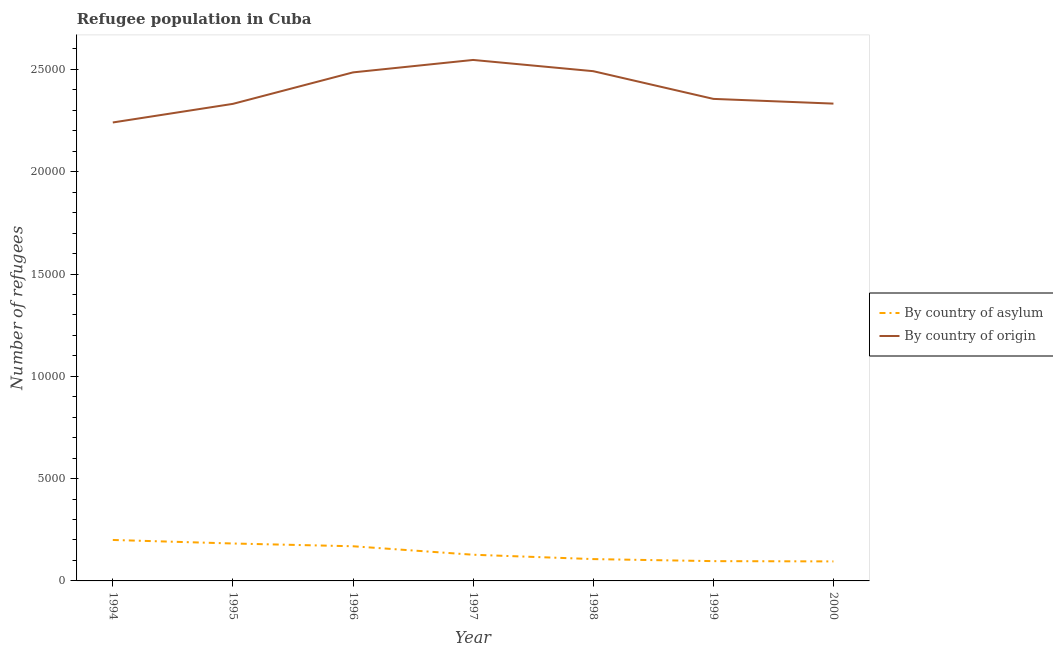Is the number of lines equal to the number of legend labels?
Offer a very short reply. Yes. What is the number of refugees by country of origin in 1999?
Make the answer very short. 2.36e+04. Across all years, what is the maximum number of refugees by country of asylum?
Ensure brevity in your answer.  2002. Across all years, what is the minimum number of refugees by country of origin?
Provide a succinct answer. 2.24e+04. In which year was the number of refugees by country of asylum maximum?
Your answer should be very brief. 1994. What is the total number of refugees by country of origin in the graph?
Offer a terse response. 1.68e+05. What is the difference between the number of refugees by country of asylum in 1998 and that in 2000?
Provide a succinct answer. 113. What is the difference between the number of refugees by country of origin in 1998 and the number of refugees by country of asylum in 2000?
Your answer should be very brief. 2.40e+04. What is the average number of refugees by country of asylum per year?
Provide a short and direct response. 1399. In the year 1997, what is the difference between the number of refugees by country of origin and number of refugees by country of asylum?
Your answer should be compact. 2.42e+04. What is the ratio of the number of refugees by country of asylum in 1996 to that in 1998?
Provide a succinct answer. 1.59. What is the difference between the highest and the second highest number of refugees by country of asylum?
Offer a very short reply. 173. What is the difference between the highest and the lowest number of refugees by country of asylum?
Your response must be concise. 1048. Is the sum of the number of refugees by country of origin in 1998 and 2000 greater than the maximum number of refugees by country of asylum across all years?
Give a very brief answer. Yes. Does the number of refugees by country of origin monotonically increase over the years?
Make the answer very short. No. Is the number of refugees by country of origin strictly greater than the number of refugees by country of asylum over the years?
Give a very brief answer. Yes. Is the number of refugees by country of origin strictly less than the number of refugees by country of asylum over the years?
Provide a succinct answer. No. What is the difference between two consecutive major ticks on the Y-axis?
Keep it short and to the point. 5000. Does the graph contain grids?
Keep it short and to the point. No. How many legend labels are there?
Your answer should be compact. 2. What is the title of the graph?
Provide a short and direct response. Refugee population in Cuba. What is the label or title of the X-axis?
Keep it short and to the point. Year. What is the label or title of the Y-axis?
Ensure brevity in your answer.  Number of refugees. What is the Number of refugees in By country of asylum in 1994?
Your answer should be compact. 2002. What is the Number of refugees of By country of origin in 1994?
Make the answer very short. 2.24e+04. What is the Number of refugees of By country of asylum in 1995?
Offer a very short reply. 1829. What is the Number of refugees of By country of origin in 1995?
Offer a terse response. 2.33e+04. What is the Number of refugees of By country of asylum in 1996?
Provide a short and direct response. 1694. What is the Number of refugees of By country of origin in 1996?
Offer a terse response. 2.49e+04. What is the Number of refugees of By country of asylum in 1997?
Offer a terse response. 1280. What is the Number of refugees of By country of origin in 1997?
Your answer should be compact. 2.55e+04. What is the Number of refugees of By country of asylum in 1998?
Give a very brief answer. 1067. What is the Number of refugees of By country of origin in 1998?
Ensure brevity in your answer.  2.49e+04. What is the Number of refugees in By country of asylum in 1999?
Keep it short and to the point. 967. What is the Number of refugees of By country of origin in 1999?
Provide a succinct answer. 2.36e+04. What is the Number of refugees of By country of asylum in 2000?
Provide a short and direct response. 954. What is the Number of refugees of By country of origin in 2000?
Keep it short and to the point. 2.33e+04. Across all years, what is the maximum Number of refugees in By country of asylum?
Make the answer very short. 2002. Across all years, what is the maximum Number of refugees of By country of origin?
Offer a very short reply. 2.55e+04. Across all years, what is the minimum Number of refugees of By country of asylum?
Offer a very short reply. 954. Across all years, what is the minimum Number of refugees of By country of origin?
Provide a succinct answer. 2.24e+04. What is the total Number of refugees of By country of asylum in the graph?
Offer a terse response. 9793. What is the total Number of refugees in By country of origin in the graph?
Ensure brevity in your answer.  1.68e+05. What is the difference between the Number of refugees in By country of asylum in 1994 and that in 1995?
Your answer should be very brief. 173. What is the difference between the Number of refugees of By country of origin in 1994 and that in 1995?
Your answer should be very brief. -910. What is the difference between the Number of refugees of By country of asylum in 1994 and that in 1996?
Make the answer very short. 308. What is the difference between the Number of refugees of By country of origin in 1994 and that in 1996?
Keep it short and to the point. -2448. What is the difference between the Number of refugees in By country of asylum in 1994 and that in 1997?
Provide a succinct answer. 722. What is the difference between the Number of refugees in By country of origin in 1994 and that in 1997?
Keep it short and to the point. -3056. What is the difference between the Number of refugees in By country of asylum in 1994 and that in 1998?
Offer a very short reply. 935. What is the difference between the Number of refugees of By country of origin in 1994 and that in 1998?
Provide a short and direct response. -2507. What is the difference between the Number of refugees of By country of asylum in 1994 and that in 1999?
Keep it short and to the point. 1035. What is the difference between the Number of refugees in By country of origin in 1994 and that in 1999?
Keep it short and to the point. -1153. What is the difference between the Number of refugees of By country of asylum in 1994 and that in 2000?
Your answer should be compact. 1048. What is the difference between the Number of refugees in By country of origin in 1994 and that in 2000?
Give a very brief answer. -922. What is the difference between the Number of refugees in By country of asylum in 1995 and that in 1996?
Make the answer very short. 135. What is the difference between the Number of refugees of By country of origin in 1995 and that in 1996?
Ensure brevity in your answer.  -1538. What is the difference between the Number of refugees of By country of asylum in 1995 and that in 1997?
Keep it short and to the point. 549. What is the difference between the Number of refugees in By country of origin in 1995 and that in 1997?
Ensure brevity in your answer.  -2146. What is the difference between the Number of refugees in By country of asylum in 1995 and that in 1998?
Your answer should be very brief. 762. What is the difference between the Number of refugees of By country of origin in 1995 and that in 1998?
Your response must be concise. -1597. What is the difference between the Number of refugees of By country of asylum in 1995 and that in 1999?
Your response must be concise. 862. What is the difference between the Number of refugees in By country of origin in 1995 and that in 1999?
Give a very brief answer. -243. What is the difference between the Number of refugees in By country of asylum in 1995 and that in 2000?
Make the answer very short. 875. What is the difference between the Number of refugees of By country of origin in 1995 and that in 2000?
Provide a short and direct response. -12. What is the difference between the Number of refugees in By country of asylum in 1996 and that in 1997?
Provide a succinct answer. 414. What is the difference between the Number of refugees of By country of origin in 1996 and that in 1997?
Offer a terse response. -608. What is the difference between the Number of refugees of By country of asylum in 1996 and that in 1998?
Your answer should be compact. 627. What is the difference between the Number of refugees of By country of origin in 1996 and that in 1998?
Offer a terse response. -59. What is the difference between the Number of refugees in By country of asylum in 1996 and that in 1999?
Offer a very short reply. 727. What is the difference between the Number of refugees of By country of origin in 1996 and that in 1999?
Make the answer very short. 1295. What is the difference between the Number of refugees of By country of asylum in 1996 and that in 2000?
Offer a terse response. 740. What is the difference between the Number of refugees in By country of origin in 1996 and that in 2000?
Provide a succinct answer. 1526. What is the difference between the Number of refugees of By country of asylum in 1997 and that in 1998?
Make the answer very short. 213. What is the difference between the Number of refugees in By country of origin in 1997 and that in 1998?
Offer a terse response. 549. What is the difference between the Number of refugees of By country of asylum in 1997 and that in 1999?
Offer a very short reply. 313. What is the difference between the Number of refugees of By country of origin in 1997 and that in 1999?
Keep it short and to the point. 1903. What is the difference between the Number of refugees in By country of asylum in 1997 and that in 2000?
Your response must be concise. 326. What is the difference between the Number of refugees in By country of origin in 1997 and that in 2000?
Provide a short and direct response. 2134. What is the difference between the Number of refugees in By country of origin in 1998 and that in 1999?
Ensure brevity in your answer.  1354. What is the difference between the Number of refugees of By country of asylum in 1998 and that in 2000?
Provide a succinct answer. 113. What is the difference between the Number of refugees in By country of origin in 1998 and that in 2000?
Your answer should be compact. 1585. What is the difference between the Number of refugees of By country of origin in 1999 and that in 2000?
Provide a short and direct response. 231. What is the difference between the Number of refugees in By country of asylum in 1994 and the Number of refugees in By country of origin in 1995?
Your answer should be compact. -2.13e+04. What is the difference between the Number of refugees in By country of asylum in 1994 and the Number of refugees in By country of origin in 1996?
Provide a succinct answer. -2.29e+04. What is the difference between the Number of refugees in By country of asylum in 1994 and the Number of refugees in By country of origin in 1997?
Your answer should be very brief. -2.35e+04. What is the difference between the Number of refugees in By country of asylum in 1994 and the Number of refugees in By country of origin in 1998?
Your response must be concise. -2.29e+04. What is the difference between the Number of refugees of By country of asylum in 1994 and the Number of refugees of By country of origin in 1999?
Your response must be concise. -2.16e+04. What is the difference between the Number of refugees in By country of asylum in 1994 and the Number of refugees in By country of origin in 2000?
Make the answer very short. -2.13e+04. What is the difference between the Number of refugees in By country of asylum in 1995 and the Number of refugees in By country of origin in 1996?
Offer a very short reply. -2.30e+04. What is the difference between the Number of refugees of By country of asylum in 1995 and the Number of refugees of By country of origin in 1997?
Make the answer very short. -2.36e+04. What is the difference between the Number of refugees of By country of asylum in 1995 and the Number of refugees of By country of origin in 1998?
Offer a terse response. -2.31e+04. What is the difference between the Number of refugees in By country of asylum in 1995 and the Number of refugees in By country of origin in 1999?
Provide a succinct answer. -2.17e+04. What is the difference between the Number of refugees of By country of asylum in 1995 and the Number of refugees of By country of origin in 2000?
Your answer should be compact. -2.15e+04. What is the difference between the Number of refugees in By country of asylum in 1996 and the Number of refugees in By country of origin in 1997?
Make the answer very short. -2.38e+04. What is the difference between the Number of refugees in By country of asylum in 1996 and the Number of refugees in By country of origin in 1998?
Make the answer very short. -2.32e+04. What is the difference between the Number of refugees of By country of asylum in 1996 and the Number of refugees of By country of origin in 1999?
Your response must be concise. -2.19e+04. What is the difference between the Number of refugees in By country of asylum in 1996 and the Number of refugees in By country of origin in 2000?
Keep it short and to the point. -2.16e+04. What is the difference between the Number of refugees of By country of asylum in 1997 and the Number of refugees of By country of origin in 1998?
Give a very brief answer. -2.36e+04. What is the difference between the Number of refugees in By country of asylum in 1997 and the Number of refugees in By country of origin in 1999?
Make the answer very short. -2.23e+04. What is the difference between the Number of refugees in By country of asylum in 1997 and the Number of refugees in By country of origin in 2000?
Your answer should be very brief. -2.20e+04. What is the difference between the Number of refugees in By country of asylum in 1998 and the Number of refugees in By country of origin in 1999?
Provide a succinct answer. -2.25e+04. What is the difference between the Number of refugees in By country of asylum in 1998 and the Number of refugees in By country of origin in 2000?
Offer a very short reply. -2.23e+04. What is the difference between the Number of refugees of By country of asylum in 1999 and the Number of refugees of By country of origin in 2000?
Provide a succinct answer. -2.24e+04. What is the average Number of refugees in By country of asylum per year?
Your response must be concise. 1399. What is the average Number of refugees of By country of origin per year?
Your response must be concise. 2.40e+04. In the year 1994, what is the difference between the Number of refugees in By country of asylum and Number of refugees in By country of origin?
Provide a short and direct response. -2.04e+04. In the year 1995, what is the difference between the Number of refugees of By country of asylum and Number of refugees of By country of origin?
Provide a short and direct response. -2.15e+04. In the year 1996, what is the difference between the Number of refugees in By country of asylum and Number of refugees in By country of origin?
Ensure brevity in your answer.  -2.32e+04. In the year 1997, what is the difference between the Number of refugees in By country of asylum and Number of refugees in By country of origin?
Offer a very short reply. -2.42e+04. In the year 1998, what is the difference between the Number of refugees of By country of asylum and Number of refugees of By country of origin?
Your answer should be compact. -2.38e+04. In the year 1999, what is the difference between the Number of refugees of By country of asylum and Number of refugees of By country of origin?
Keep it short and to the point. -2.26e+04. In the year 2000, what is the difference between the Number of refugees in By country of asylum and Number of refugees in By country of origin?
Make the answer very short. -2.24e+04. What is the ratio of the Number of refugees of By country of asylum in 1994 to that in 1995?
Offer a very short reply. 1.09. What is the ratio of the Number of refugees of By country of origin in 1994 to that in 1995?
Your answer should be compact. 0.96. What is the ratio of the Number of refugees in By country of asylum in 1994 to that in 1996?
Your answer should be compact. 1.18. What is the ratio of the Number of refugees of By country of origin in 1994 to that in 1996?
Your response must be concise. 0.9. What is the ratio of the Number of refugees in By country of asylum in 1994 to that in 1997?
Your response must be concise. 1.56. What is the ratio of the Number of refugees of By country of origin in 1994 to that in 1997?
Provide a short and direct response. 0.88. What is the ratio of the Number of refugees of By country of asylum in 1994 to that in 1998?
Offer a very short reply. 1.88. What is the ratio of the Number of refugees in By country of origin in 1994 to that in 1998?
Provide a short and direct response. 0.9. What is the ratio of the Number of refugees in By country of asylum in 1994 to that in 1999?
Ensure brevity in your answer.  2.07. What is the ratio of the Number of refugees of By country of origin in 1994 to that in 1999?
Make the answer very short. 0.95. What is the ratio of the Number of refugees in By country of asylum in 1994 to that in 2000?
Provide a succinct answer. 2.1. What is the ratio of the Number of refugees in By country of origin in 1994 to that in 2000?
Provide a succinct answer. 0.96. What is the ratio of the Number of refugees in By country of asylum in 1995 to that in 1996?
Offer a very short reply. 1.08. What is the ratio of the Number of refugees of By country of origin in 1995 to that in 1996?
Provide a short and direct response. 0.94. What is the ratio of the Number of refugees of By country of asylum in 1995 to that in 1997?
Your response must be concise. 1.43. What is the ratio of the Number of refugees in By country of origin in 1995 to that in 1997?
Your answer should be compact. 0.92. What is the ratio of the Number of refugees in By country of asylum in 1995 to that in 1998?
Keep it short and to the point. 1.71. What is the ratio of the Number of refugees in By country of origin in 1995 to that in 1998?
Your response must be concise. 0.94. What is the ratio of the Number of refugees in By country of asylum in 1995 to that in 1999?
Keep it short and to the point. 1.89. What is the ratio of the Number of refugees in By country of asylum in 1995 to that in 2000?
Your response must be concise. 1.92. What is the ratio of the Number of refugees in By country of asylum in 1996 to that in 1997?
Provide a short and direct response. 1.32. What is the ratio of the Number of refugees of By country of origin in 1996 to that in 1997?
Keep it short and to the point. 0.98. What is the ratio of the Number of refugees of By country of asylum in 1996 to that in 1998?
Your answer should be very brief. 1.59. What is the ratio of the Number of refugees of By country of asylum in 1996 to that in 1999?
Your response must be concise. 1.75. What is the ratio of the Number of refugees of By country of origin in 1996 to that in 1999?
Make the answer very short. 1.05. What is the ratio of the Number of refugees in By country of asylum in 1996 to that in 2000?
Your answer should be compact. 1.78. What is the ratio of the Number of refugees in By country of origin in 1996 to that in 2000?
Give a very brief answer. 1.07. What is the ratio of the Number of refugees in By country of asylum in 1997 to that in 1998?
Provide a short and direct response. 1.2. What is the ratio of the Number of refugees in By country of asylum in 1997 to that in 1999?
Your response must be concise. 1.32. What is the ratio of the Number of refugees of By country of origin in 1997 to that in 1999?
Your response must be concise. 1.08. What is the ratio of the Number of refugees of By country of asylum in 1997 to that in 2000?
Make the answer very short. 1.34. What is the ratio of the Number of refugees of By country of origin in 1997 to that in 2000?
Provide a succinct answer. 1.09. What is the ratio of the Number of refugees of By country of asylum in 1998 to that in 1999?
Give a very brief answer. 1.1. What is the ratio of the Number of refugees in By country of origin in 1998 to that in 1999?
Your answer should be compact. 1.06. What is the ratio of the Number of refugees in By country of asylum in 1998 to that in 2000?
Make the answer very short. 1.12. What is the ratio of the Number of refugees of By country of origin in 1998 to that in 2000?
Your answer should be very brief. 1.07. What is the ratio of the Number of refugees in By country of asylum in 1999 to that in 2000?
Ensure brevity in your answer.  1.01. What is the ratio of the Number of refugees of By country of origin in 1999 to that in 2000?
Ensure brevity in your answer.  1.01. What is the difference between the highest and the second highest Number of refugees in By country of asylum?
Give a very brief answer. 173. What is the difference between the highest and the second highest Number of refugees of By country of origin?
Your answer should be compact. 549. What is the difference between the highest and the lowest Number of refugees of By country of asylum?
Give a very brief answer. 1048. What is the difference between the highest and the lowest Number of refugees of By country of origin?
Make the answer very short. 3056. 